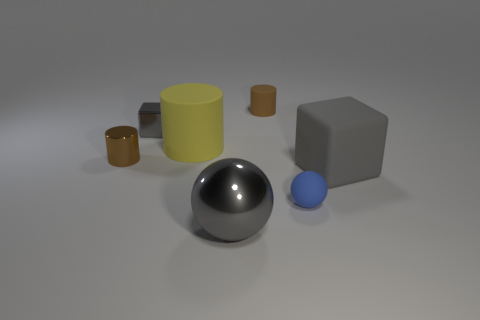Subtract all tiny metal cylinders. How many cylinders are left? 2 Add 3 big gray spheres. How many objects exist? 10 Subtract all yellow cylinders. How many cylinders are left? 2 Subtract all balls. How many objects are left? 5 Subtract 1 cylinders. How many cylinders are left? 2 Subtract 0 red cylinders. How many objects are left? 7 Subtract all purple cylinders. Subtract all gray blocks. How many cylinders are left? 3 Subtract all brown cubes. How many blue balls are left? 1 Subtract all big green cylinders. Subtract all large things. How many objects are left? 4 Add 6 large matte cubes. How many large matte cubes are left? 7 